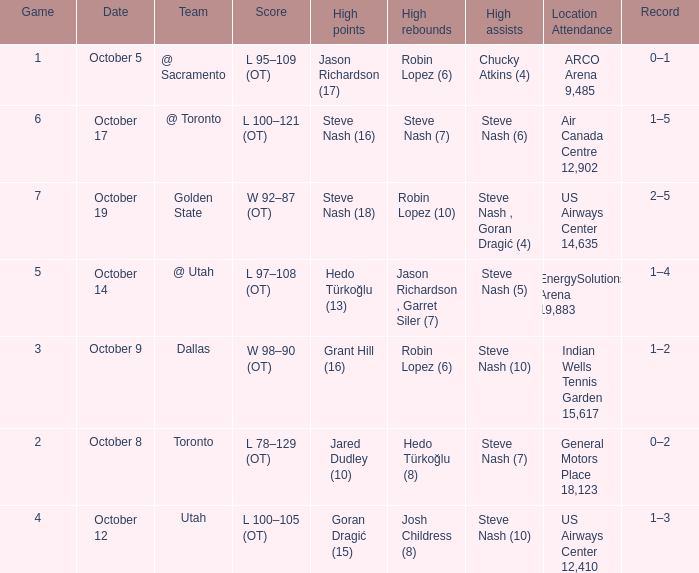What two players had the highest rebounds for the October 14 game? Jason Richardson , Garret Siler (7). 